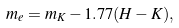<formula> <loc_0><loc_0><loc_500><loc_500>m _ { e } = m _ { K } - 1 . 7 7 ( H - K ) ,</formula> 